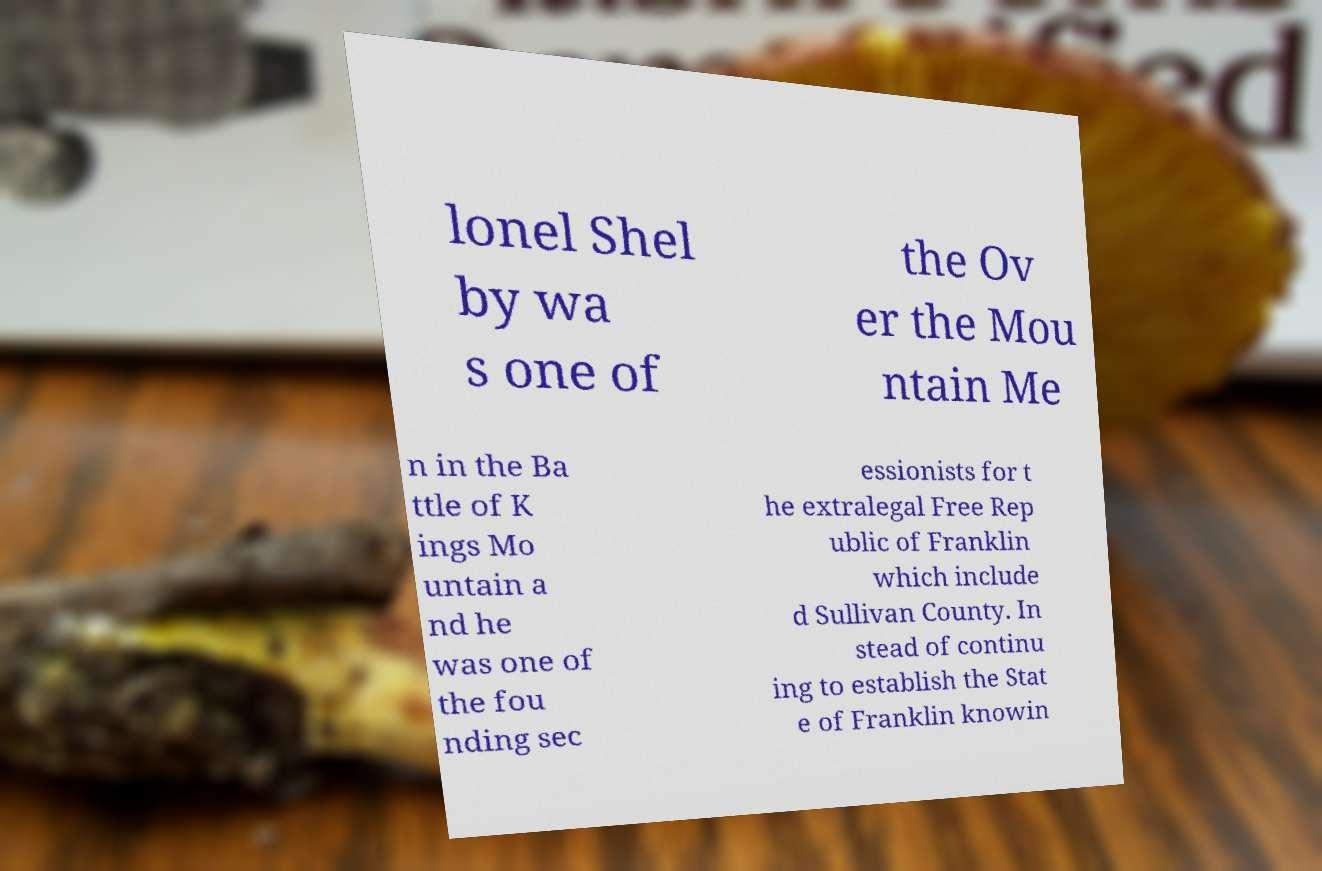Can you read and provide the text displayed in the image?This photo seems to have some interesting text. Can you extract and type it out for me? lonel Shel by wa s one of the Ov er the Mou ntain Me n in the Ba ttle of K ings Mo untain a nd he was one of the fou nding sec essionists for t he extralegal Free Rep ublic of Franklin which include d Sullivan County. In stead of continu ing to establish the Stat e of Franklin knowin 